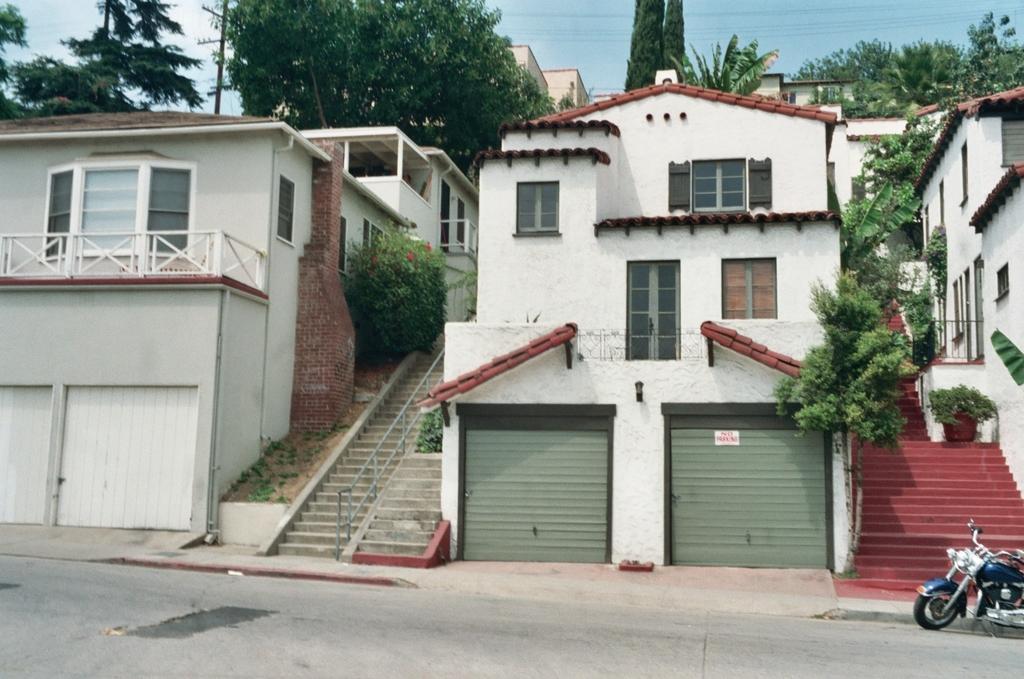How would you summarize this image in a sentence or two? In this image we can see there are buildings with stairs and there are shutters. In front of the building we can see the motorcycle on the road. And there are trees, potted plant, pole and the sky. 